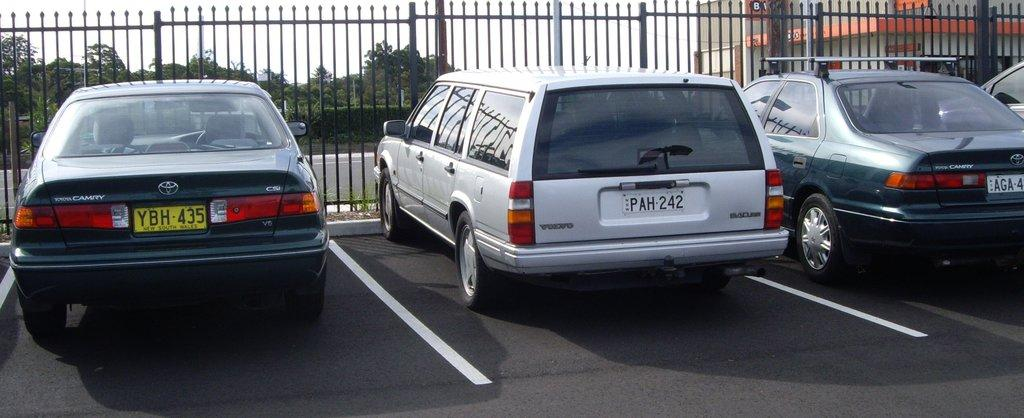How many cars are parked on the road in the image? There are four cars parked on the road in the image. What is near the cars in the image? The cars are near a fence in the image. What can be seen in the background of the image? There are trees, plants, grass, a road, and the sky visible in the background of the image. Where is the building located in the image? The building is on the right side of the image. What type of wind can be seen blowing through the trees in the image? There is no wind visible in the image; it is a still image. How many trains are passing by in the image? There are no trains present in the image. 